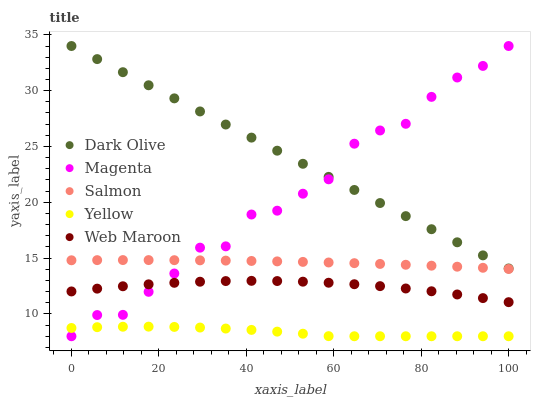Does Yellow have the minimum area under the curve?
Answer yes or no. Yes. Does Dark Olive have the maximum area under the curve?
Answer yes or no. Yes. Does Magenta have the minimum area under the curve?
Answer yes or no. No. Does Magenta have the maximum area under the curve?
Answer yes or no. No. Is Dark Olive the smoothest?
Answer yes or no. Yes. Is Magenta the roughest?
Answer yes or no. Yes. Is Magenta the smoothest?
Answer yes or no. No. Is Dark Olive the roughest?
Answer yes or no. No. Does Magenta have the lowest value?
Answer yes or no. Yes. Does Dark Olive have the lowest value?
Answer yes or no. No. Does Dark Olive have the highest value?
Answer yes or no. Yes. Does Salmon have the highest value?
Answer yes or no. No. Is Yellow less than Dark Olive?
Answer yes or no. Yes. Is Web Maroon greater than Yellow?
Answer yes or no. Yes. Does Web Maroon intersect Magenta?
Answer yes or no. Yes. Is Web Maroon less than Magenta?
Answer yes or no. No. Is Web Maroon greater than Magenta?
Answer yes or no. No. Does Yellow intersect Dark Olive?
Answer yes or no. No. 